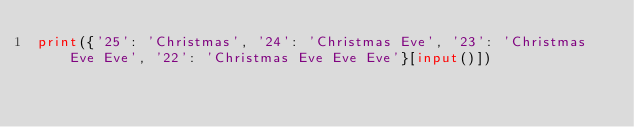Convert code to text. <code><loc_0><loc_0><loc_500><loc_500><_Python_>print({'25': 'Christmas', '24': 'Christmas Eve', '23': 'Christmas Eve Eve', '22': 'Christmas Eve Eve Eve'}[input()])</code> 